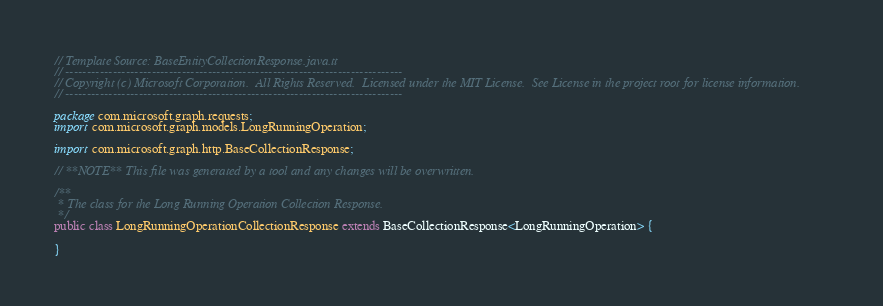<code> <loc_0><loc_0><loc_500><loc_500><_Java_>// Template Source: BaseEntityCollectionResponse.java.tt
// ------------------------------------------------------------------------------
// Copyright (c) Microsoft Corporation.  All Rights Reserved.  Licensed under the MIT License.  See License in the project root for license information.
// ------------------------------------------------------------------------------

package com.microsoft.graph.requests;
import com.microsoft.graph.models.LongRunningOperation;

import com.microsoft.graph.http.BaseCollectionResponse;

// **NOTE** This file was generated by a tool and any changes will be overwritten.

/**
 * The class for the Long Running Operation Collection Response.
 */
public class LongRunningOperationCollectionResponse extends BaseCollectionResponse<LongRunningOperation> {

}
</code> 